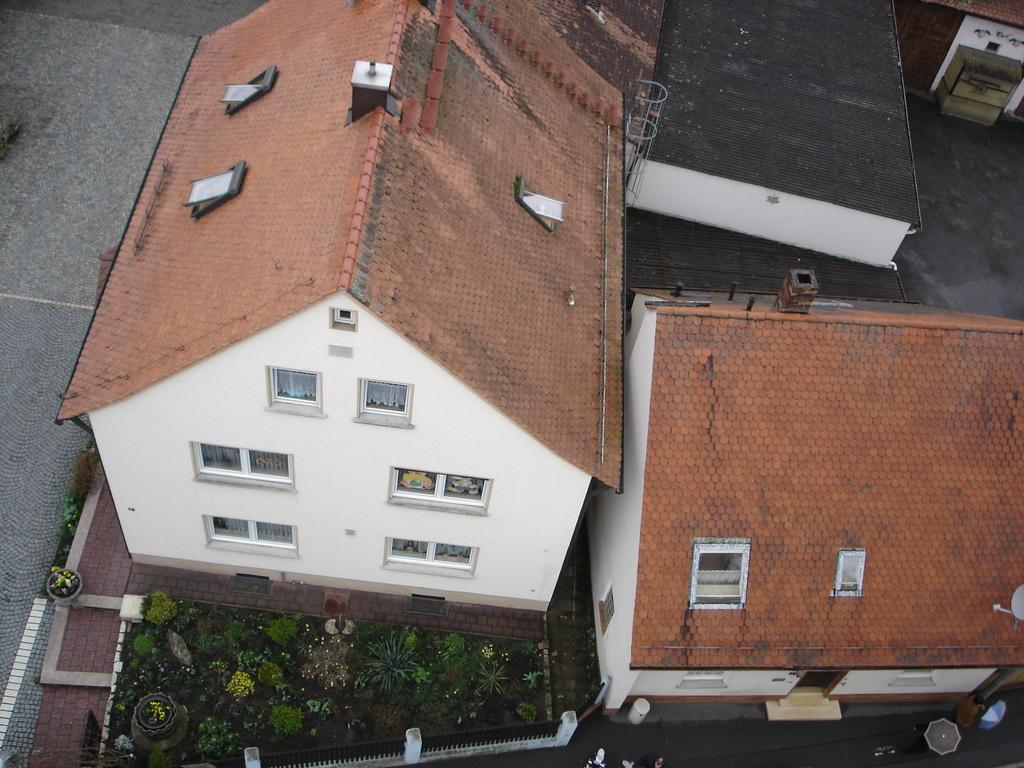What type of structures can be seen in the image? There are houses in the image. What other elements are present in the image besides the houses? There are plants and a fence in the image. What reward is being given to the parent in the image? There is no reward or parent present in the image; it only features houses, plants, and a fence. 